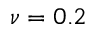Convert formula to latex. <formula><loc_0><loc_0><loc_500><loc_500>\nu = 0 . 2</formula> 